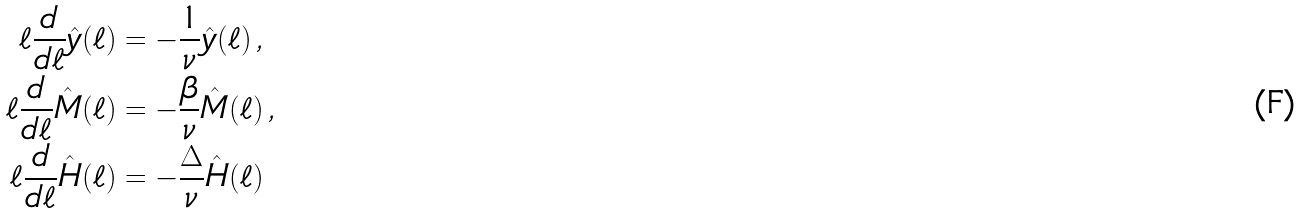<formula> <loc_0><loc_0><loc_500><loc_500>\ell \frac { d } { d \ell } \hat { y } ( \ell ) & = - \frac { 1 } { \nu } \hat { y } ( \ell ) \, , \\ \ell \frac { d } { d \ell } \hat { M } ( \ell ) & = - \frac { \beta } { \nu } \hat { M } ( \ell ) \, , \\ \ell \frac { d } { d \ell } \hat { H } ( \ell ) & = - \frac { \Delta } { \nu } \hat { H } ( \ell ) \,</formula> 